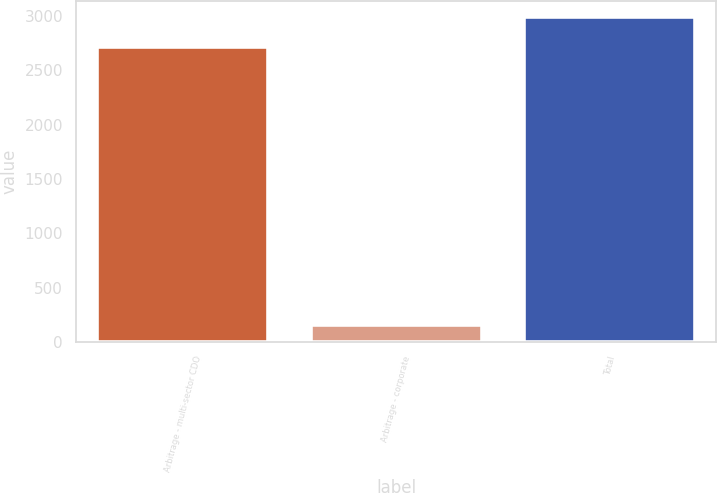<chart> <loc_0><loc_0><loc_500><loc_500><bar_chart><fcel>Arbitrage - multi-sector CDO<fcel>Arbitrage - corporate<fcel>Total<nl><fcel>2718<fcel>161<fcel>2989.8<nl></chart> 